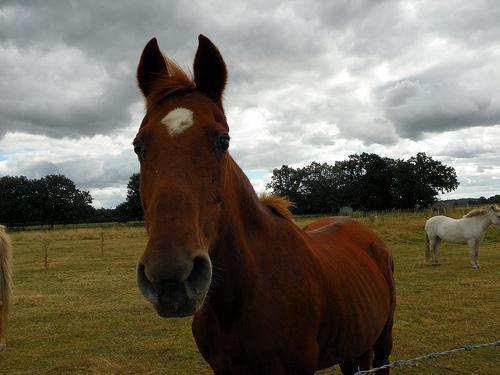How many horses are in this photo?
Give a very brief answer. 2. 